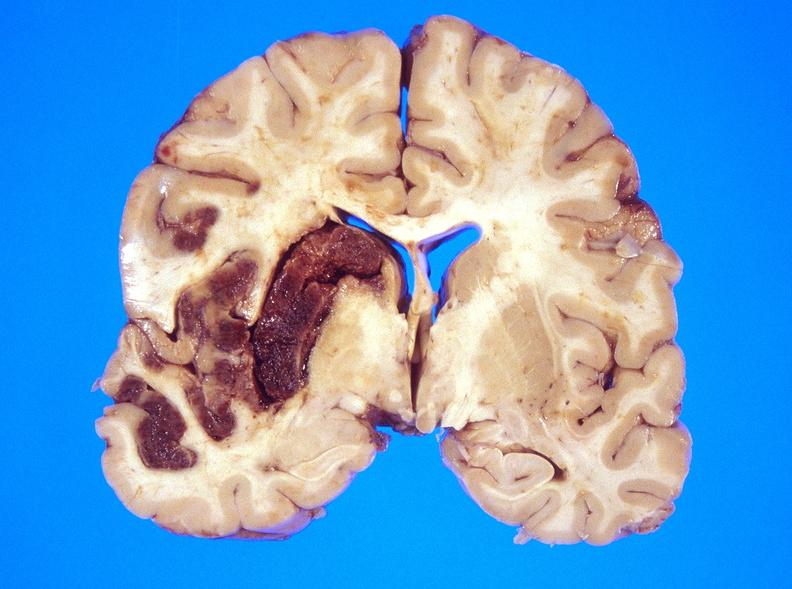does this image show hemorrhagic reperfusion infarct, middle cerebral artery l?
Answer the question using a single word or phrase. Yes 